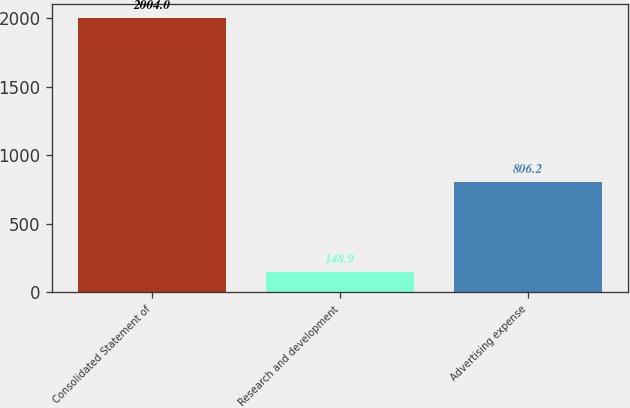Convert chart. <chart><loc_0><loc_0><loc_500><loc_500><bar_chart><fcel>Consolidated Statement of<fcel>Research and development<fcel>Advertising expense<nl><fcel>2004<fcel>148.9<fcel>806.2<nl></chart> 